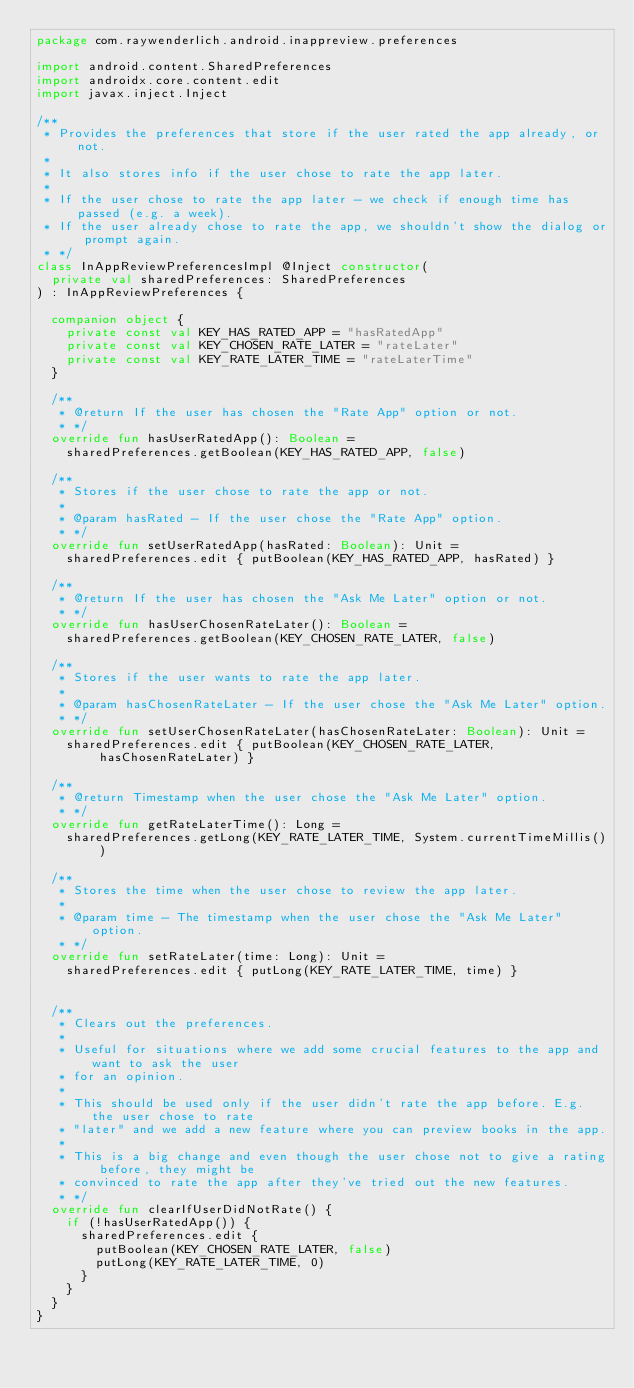<code> <loc_0><loc_0><loc_500><loc_500><_Kotlin_>package com.raywenderlich.android.inappreview.preferences

import android.content.SharedPreferences
import androidx.core.content.edit
import javax.inject.Inject

/**
 * Provides the preferences that store if the user rated the app already, or not.
 *
 * It also stores info if the user chose to rate the app later.
 *
 * If the user chose to rate the app later - we check if enough time has passed (e.g. a week).
 * If the user already chose to rate the app, we shouldn't show the dialog or prompt again.
 * */
class InAppReviewPreferencesImpl @Inject constructor(
  private val sharedPreferences: SharedPreferences
) : InAppReviewPreferences {

  companion object {
    private const val KEY_HAS_RATED_APP = "hasRatedApp"
    private const val KEY_CHOSEN_RATE_LATER = "rateLater"
    private const val KEY_RATE_LATER_TIME = "rateLaterTime"
  }

  /**
   * @return If the user has chosen the "Rate App" option or not.
   * */
  override fun hasUserRatedApp(): Boolean =
    sharedPreferences.getBoolean(KEY_HAS_RATED_APP, false)

  /**
   * Stores if the user chose to rate the app or not.
   *
   * @param hasRated - If the user chose the "Rate App" option.
   * */
  override fun setUserRatedApp(hasRated: Boolean): Unit =
    sharedPreferences.edit { putBoolean(KEY_HAS_RATED_APP, hasRated) }

  /**
   * @return If the user has chosen the "Ask Me Later" option or not.
   * */
  override fun hasUserChosenRateLater(): Boolean =
    sharedPreferences.getBoolean(KEY_CHOSEN_RATE_LATER, false)

  /**
   * Stores if the user wants to rate the app later.
   *
   * @param hasChosenRateLater - If the user chose the "Ask Me Later" option.
   * */
  override fun setUserChosenRateLater(hasChosenRateLater: Boolean): Unit =
    sharedPreferences.edit { putBoolean(KEY_CHOSEN_RATE_LATER, hasChosenRateLater) }

  /**
   * @return Timestamp when the user chose the "Ask Me Later" option.
   * */
  override fun getRateLaterTime(): Long =
    sharedPreferences.getLong(KEY_RATE_LATER_TIME, System.currentTimeMillis())

  /**
   * Stores the time when the user chose to review the app later.
   *
   * @param time - The timestamp when the user chose the "Ask Me Later" option.
   * */
  override fun setRateLater(time: Long): Unit =
    sharedPreferences.edit { putLong(KEY_RATE_LATER_TIME, time) }


  /**
   * Clears out the preferences.
   *
   * Useful for situations where we add some crucial features to the app and want to ask the user
   * for an opinion.
   *
   * This should be used only if the user didn't rate the app before. E.g. the user chose to rate
   * "later" and we add a new feature where you can preview books in the app.
   *
   * This is a big change and even though the user chose not to give a rating before, they might be
   * convinced to rate the app after they've tried out the new features.
   * */
  override fun clearIfUserDidNotRate() {
    if (!hasUserRatedApp()) {
      sharedPreferences.edit {
        putBoolean(KEY_CHOSEN_RATE_LATER, false)
        putLong(KEY_RATE_LATER_TIME, 0)
      }
    }
  }
}</code> 